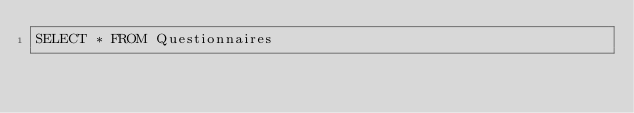Convert code to text. <code><loc_0><loc_0><loc_500><loc_500><_SQL_>SELECT * FROM Questionnaires</code> 